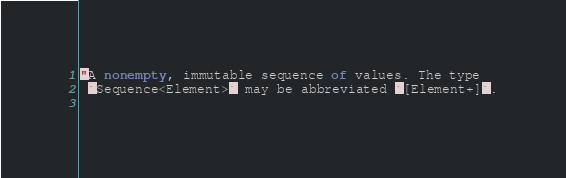Convert code to text. <code><loc_0><loc_0><loc_500><loc_500><_Ceylon_>"A nonempty, immutable sequence of values. The type 
 `Sequence<Element>` may be abbreviated `[Element+]`.
 </code> 